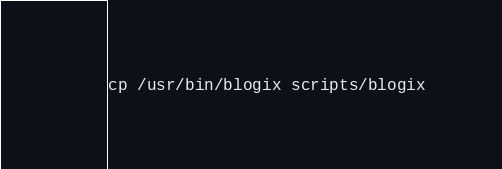Convert code to text. <code><loc_0><loc_0><loc_500><loc_500><_Bash_>
cp /usr/bin/blogix scripts/blogix
</code> 